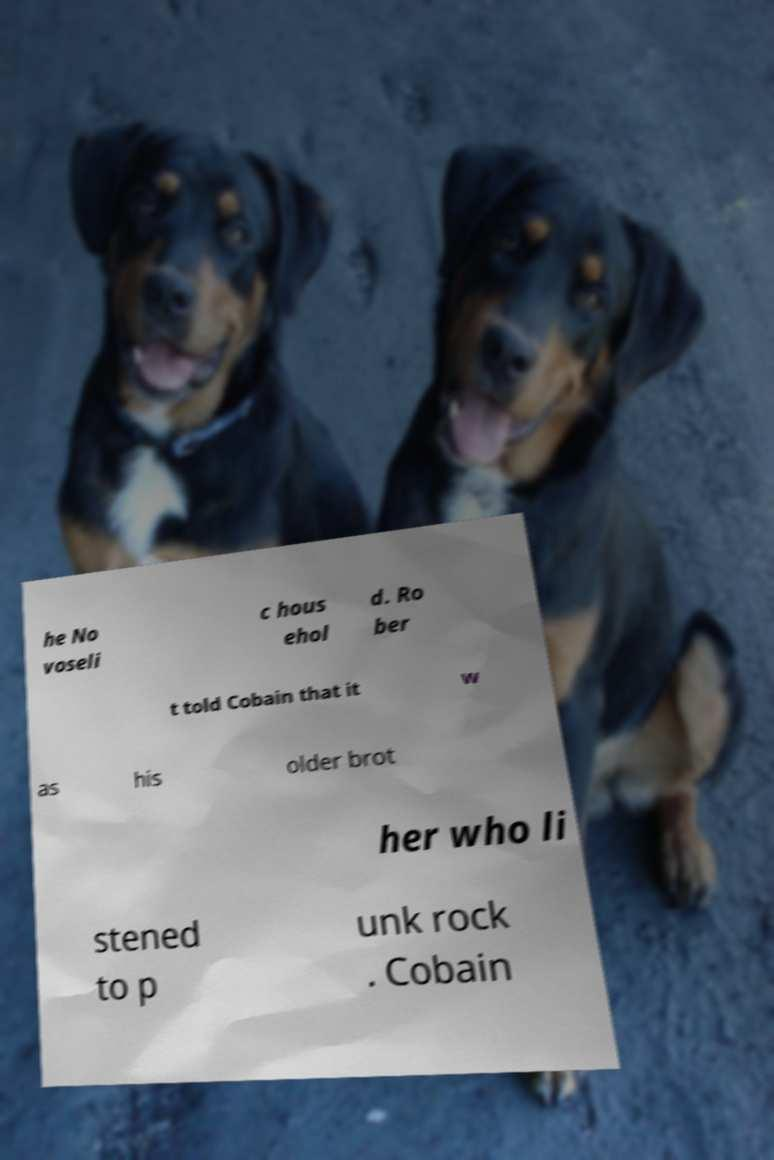I need the written content from this picture converted into text. Can you do that? he No voseli c hous ehol d. Ro ber t told Cobain that it w as his older brot her who li stened to p unk rock . Cobain 